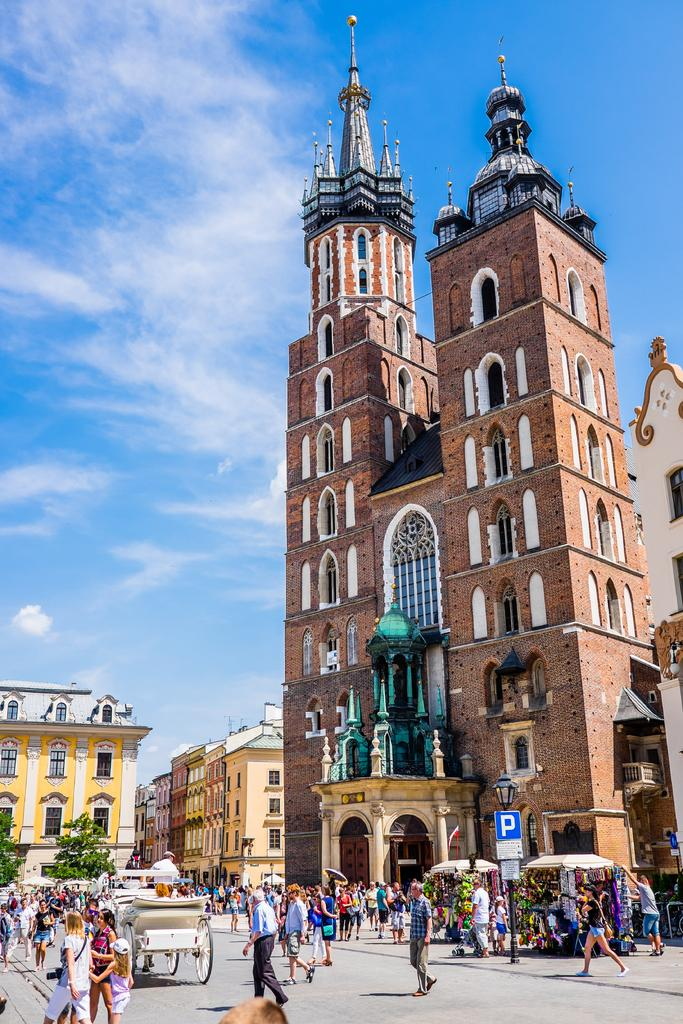What type of structures can be seen in the image? There are buildings in the image. What else can be seen in the image besides buildings? There are poles and trees in the image. What is happening on the road in the image? There is a crowd on the road in the image. How would you describe the sky in the image? The sky is clear in the image. What type of advertisement can be seen on the trees in the image? There are no advertisements visible on the trees in the image; only trees are present. What is the mass of the dirt on the road in the image? There is no dirt visible on the road in the image, so it is not possible to determine its mass. 